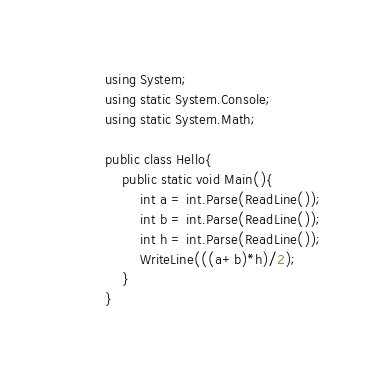<code> <loc_0><loc_0><loc_500><loc_500><_C#_>using System;
using static System.Console;
using static System.Math;

public class Hello{
    public static void Main(){
        int a = int.Parse(ReadLine());
        int b = int.Parse(ReadLine());
        int h = int.Parse(ReadLine());
        WriteLine(((a+b)*h)/2);
    }
}
</code> 